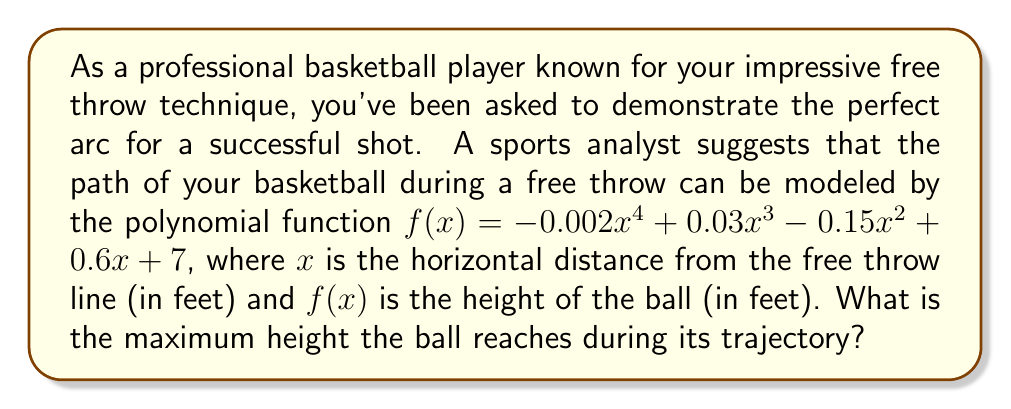Solve this math problem. To find the maximum height of the ball, we need to determine the highest point of the polynomial function. This occurs at the vertex of the parabola-like curve. We can find this by following these steps:

1) First, we need to find the derivative of the function:
   $$f'(x) = -0.008x^3 + 0.09x^2 - 0.3x + 0.6$$

2) The maximum height occurs where the derivative equals zero. So, we set $f'(x) = 0$:
   $$-0.008x^3 + 0.09x^2 - 0.3x + 0.6 = 0$$

3) This is a cubic equation, which is challenging to solve by hand. In a real-world scenario, we would use a graphing calculator or computer software to find the roots of this equation.

4) Using such tools, we find that this equation has three roots: approximately -2.85, 3.75, and 10.35.

5) Since we're modeling a free throw, which typically travels about 15 feet horizontally, the root we're interested in is 3.75 feet.

6) To confirm this is a maximum (not a minimum), we could check the second derivative is negative at this point, but we'll skip this step for brevity.

7) Now that we know the x-coordinate of the highest point, we plug this back into our original function to find the maximum height:

   $$f(3.75) = -0.002(3.75)^4 + 0.03(3.75)^3 - 0.15(3.75)^2 + 0.6(3.75) + 7$$

8) Calculating this (again, using a calculator for accuracy):
   $$f(3.75) \approx 8.64$$

Therefore, the maximum height the ball reaches is approximately 8.64 feet.
Answer: The maximum height the ball reaches during its trajectory is approximately 8.64 feet. 